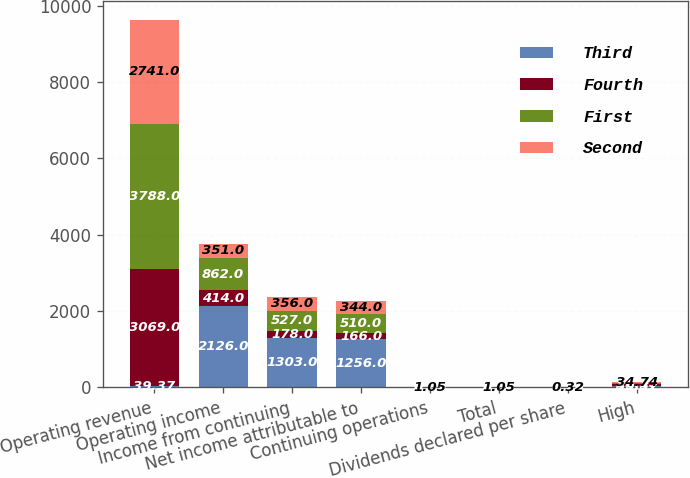<chart> <loc_0><loc_0><loc_500><loc_500><stacked_bar_chart><ecel><fcel>Operating revenue<fcel>Operating income<fcel>Income from continuing<fcel>Net income attributable to<fcel>Continuing operations<fcel>Total<fcel>Dividends declared per share<fcel>High<nl><fcel>Third<fcel>39.37<fcel>2126<fcel>1303<fcel>1256<fcel>3.83<fcel>3.84<fcel>1.26<fcel>39.37<nl><fcel>Fourth<fcel>3069<fcel>414<fcel>178<fcel>166<fcel>0.51<fcel>0.51<fcel>0.32<fcel>39.37<nl><fcel>First<fcel>3788<fcel>862<fcel>527<fcel>510<fcel>1.57<fcel>1.56<fcel>0.32<fcel>35.15<nl><fcel>Second<fcel>2741<fcel>351<fcel>356<fcel>344<fcel>1.05<fcel>1.05<fcel>0.32<fcel>34.74<nl></chart> 